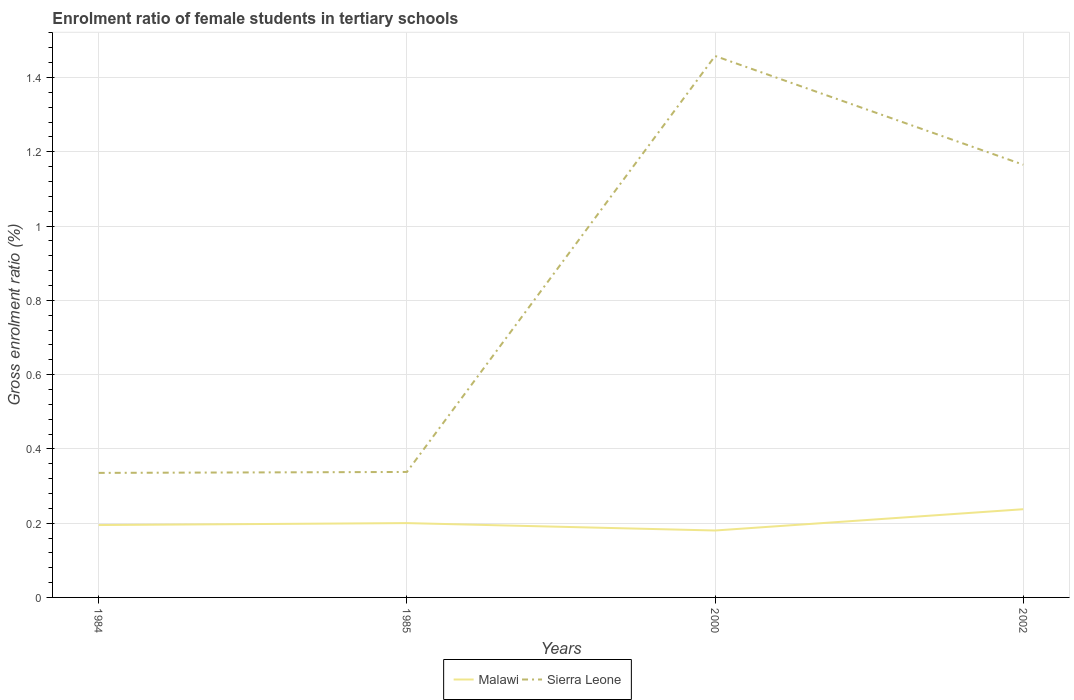Across all years, what is the maximum enrolment ratio of female students in tertiary schools in Sierra Leone?
Ensure brevity in your answer.  0.34. In which year was the enrolment ratio of female students in tertiary schools in Malawi maximum?
Ensure brevity in your answer.  2000. What is the total enrolment ratio of female students in tertiary schools in Sierra Leone in the graph?
Your response must be concise. -0.83. What is the difference between the highest and the second highest enrolment ratio of female students in tertiary schools in Sierra Leone?
Your answer should be compact. 1.12. Is the enrolment ratio of female students in tertiary schools in Sierra Leone strictly greater than the enrolment ratio of female students in tertiary schools in Malawi over the years?
Make the answer very short. No. How many years are there in the graph?
Make the answer very short. 4. Are the values on the major ticks of Y-axis written in scientific E-notation?
Ensure brevity in your answer.  No. Does the graph contain any zero values?
Give a very brief answer. No. Does the graph contain grids?
Offer a terse response. Yes. How many legend labels are there?
Give a very brief answer. 2. How are the legend labels stacked?
Offer a very short reply. Horizontal. What is the title of the graph?
Your answer should be compact. Enrolment ratio of female students in tertiary schools. Does "Mozambique" appear as one of the legend labels in the graph?
Provide a succinct answer. No. What is the label or title of the Y-axis?
Provide a succinct answer. Gross enrolment ratio (%). What is the Gross enrolment ratio (%) in Malawi in 1984?
Your answer should be compact. 0.19. What is the Gross enrolment ratio (%) in Sierra Leone in 1984?
Keep it short and to the point. 0.34. What is the Gross enrolment ratio (%) in Malawi in 1985?
Provide a short and direct response. 0.2. What is the Gross enrolment ratio (%) in Sierra Leone in 1985?
Give a very brief answer. 0.34. What is the Gross enrolment ratio (%) of Malawi in 2000?
Your response must be concise. 0.18. What is the Gross enrolment ratio (%) in Sierra Leone in 2000?
Ensure brevity in your answer.  1.46. What is the Gross enrolment ratio (%) of Malawi in 2002?
Provide a succinct answer. 0.24. What is the Gross enrolment ratio (%) of Sierra Leone in 2002?
Make the answer very short. 1.17. Across all years, what is the maximum Gross enrolment ratio (%) of Malawi?
Provide a succinct answer. 0.24. Across all years, what is the maximum Gross enrolment ratio (%) in Sierra Leone?
Keep it short and to the point. 1.46. Across all years, what is the minimum Gross enrolment ratio (%) in Malawi?
Provide a short and direct response. 0.18. Across all years, what is the minimum Gross enrolment ratio (%) of Sierra Leone?
Keep it short and to the point. 0.34. What is the total Gross enrolment ratio (%) in Malawi in the graph?
Provide a succinct answer. 0.81. What is the total Gross enrolment ratio (%) in Sierra Leone in the graph?
Offer a terse response. 3.3. What is the difference between the Gross enrolment ratio (%) in Malawi in 1984 and that in 1985?
Make the answer very short. -0.01. What is the difference between the Gross enrolment ratio (%) of Sierra Leone in 1984 and that in 1985?
Offer a very short reply. -0. What is the difference between the Gross enrolment ratio (%) of Malawi in 1984 and that in 2000?
Your answer should be compact. 0.01. What is the difference between the Gross enrolment ratio (%) of Sierra Leone in 1984 and that in 2000?
Provide a succinct answer. -1.12. What is the difference between the Gross enrolment ratio (%) in Malawi in 1984 and that in 2002?
Provide a short and direct response. -0.04. What is the difference between the Gross enrolment ratio (%) in Sierra Leone in 1984 and that in 2002?
Give a very brief answer. -0.83. What is the difference between the Gross enrolment ratio (%) in Malawi in 1985 and that in 2000?
Make the answer very short. 0.02. What is the difference between the Gross enrolment ratio (%) of Sierra Leone in 1985 and that in 2000?
Your answer should be very brief. -1.12. What is the difference between the Gross enrolment ratio (%) of Malawi in 1985 and that in 2002?
Give a very brief answer. -0.04. What is the difference between the Gross enrolment ratio (%) in Sierra Leone in 1985 and that in 2002?
Your answer should be compact. -0.83. What is the difference between the Gross enrolment ratio (%) of Malawi in 2000 and that in 2002?
Make the answer very short. -0.06. What is the difference between the Gross enrolment ratio (%) of Sierra Leone in 2000 and that in 2002?
Keep it short and to the point. 0.29. What is the difference between the Gross enrolment ratio (%) in Malawi in 1984 and the Gross enrolment ratio (%) in Sierra Leone in 1985?
Offer a very short reply. -0.14. What is the difference between the Gross enrolment ratio (%) in Malawi in 1984 and the Gross enrolment ratio (%) in Sierra Leone in 2000?
Your answer should be very brief. -1.26. What is the difference between the Gross enrolment ratio (%) of Malawi in 1984 and the Gross enrolment ratio (%) of Sierra Leone in 2002?
Ensure brevity in your answer.  -0.97. What is the difference between the Gross enrolment ratio (%) in Malawi in 1985 and the Gross enrolment ratio (%) in Sierra Leone in 2000?
Give a very brief answer. -1.26. What is the difference between the Gross enrolment ratio (%) of Malawi in 1985 and the Gross enrolment ratio (%) of Sierra Leone in 2002?
Give a very brief answer. -0.96. What is the difference between the Gross enrolment ratio (%) of Malawi in 2000 and the Gross enrolment ratio (%) of Sierra Leone in 2002?
Provide a short and direct response. -0.98. What is the average Gross enrolment ratio (%) in Malawi per year?
Keep it short and to the point. 0.2. What is the average Gross enrolment ratio (%) of Sierra Leone per year?
Give a very brief answer. 0.82. In the year 1984, what is the difference between the Gross enrolment ratio (%) of Malawi and Gross enrolment ratio (%) of Sierra Leone?
Offer a very short reply. -0.14. In the year 1985, what is the difference between the Gross enrolment ratio (%) of Malawi and Gross enrolment ratio (%) of Sierra Leone?
Your answer should be compact. -0.14. In the year 2000, what is the difference between the Gross enrolment ratio (%) in Malawi and Gross enrolment ratio (%) in Sierra Leone?
Provide a short and direct response. -1.28. In the year 2002, what is the difference between the Gross enrolment ratio (%) of Malawi and Gross enrolment ratio (%) of Sierra Leone?
Ensure brevity in your answer.  -0.93. What is the ratio of the Gross enrolment ratio (%) in Malawi in 1984 to that in 1985?
Your response must be concise. 0.97. What is the ratio of the Gross enrolment ratio (%) in Malawi in 1984 to that in 2000?
Your answer should be compact. 1.08. What is the ratio of the Gross enrolment ratio (%) of Sierra Leone in 1984 to that in 2000?
Your answer should be very brief. 0.23. What is the ratio of the Gross enrolment ratio (%) of Malawi in 1984 to that in 2002?
Your answer should be very brief. 0.82. What is the ratio of the Gross enrolment ratio (%) of Sierra Leone in 1984 to that in 2002?
Keep it short and to the point. 0.29. What is the ratio of the Gross enrolment ratio (%) of Malawi in 1985 to that in 2000?
Give a very brief answer. 1.11. What is the ratio of the Gross enrolment ratio (%) of Sierra Leone in 1985 to that in 2000?
Give a very brief answer. 0.23. What is the ratio of the Gross enrolment ratio (%) in Malawi in 1985 to that in 2002?
Keep it short and to the point. 0.84. What is the ratio of the Gross enrolment ratio (%) of Sierra Leone in 1985 to that in 2002?
Provide a short and direct response. 0.29. What is the ratio of the Gross enrolment ratio (%) in Malawi in 2000 to that in 2002?
Provide a short and direct response. 0.76. What is the ratio of the Gross enrolment ratio (%) in Sierra Leone in 2000 to that in 2002?
Your answer should be very brief. 1.25. What is the difference between the highest and the second highest Gross enrolment ratio (%) in Malawi?
Provide a short and direct response. 0.04. What is the difference between the highest and the second highest Gross enrolment ratio (%) of Sierra Leone?
Your response must be concise. 0.29. What is the difference between the highest and the lowest Gross enrolment ratio (%) of Malawi?
Provide a short and direct response. 0.06. What is the difference between the highest and the lowest Gross enrolment ratio (%) in Sierra Leone?
Offer a terse response. 1.12. 